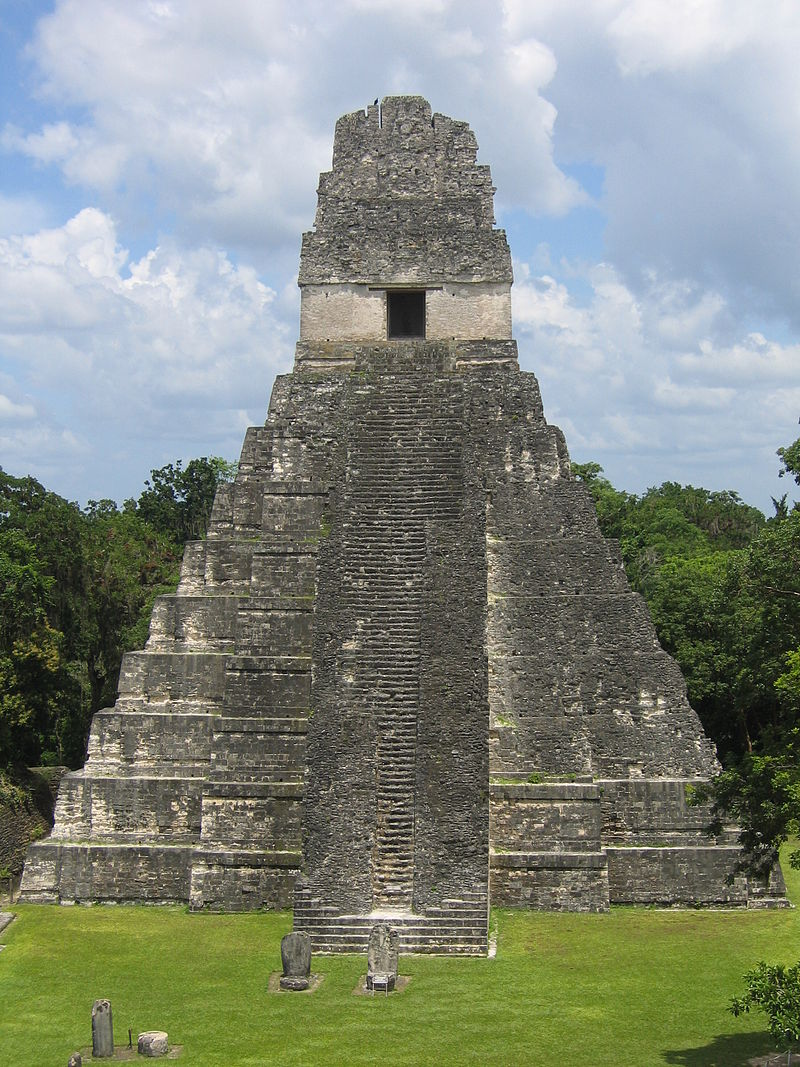If this temple could talk, what stories would it tell? If Tikal Temple I could talk, it would recount tales of grand ceremonies held in its shadows, where priests and kings performed intricate rituals under the watchful eyes of their gods. It would speak of the countless workers who toiled to raise its stones, each one a testament to the community's devotion. The temple would recall the vibrant life of the city around it—traders, artisans, and farmers contributing to the bustling metropolis of Tikal. It would also mourn the eventual decline of its civilization, as the jungle began to reclaim what was once a thriving center of power and spirituality. 